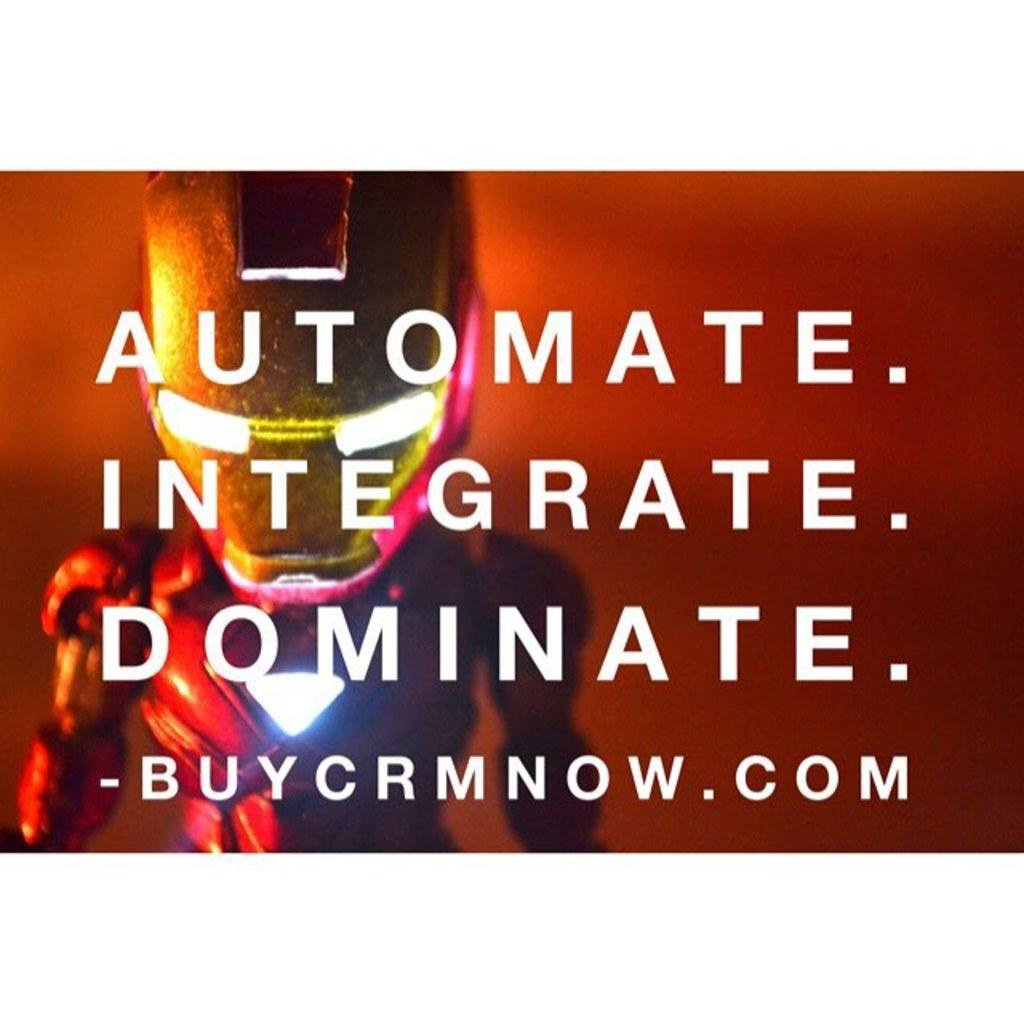<image>
Summarize the visual content of the image. a sign with an Iron Man mask that says Buy on it 